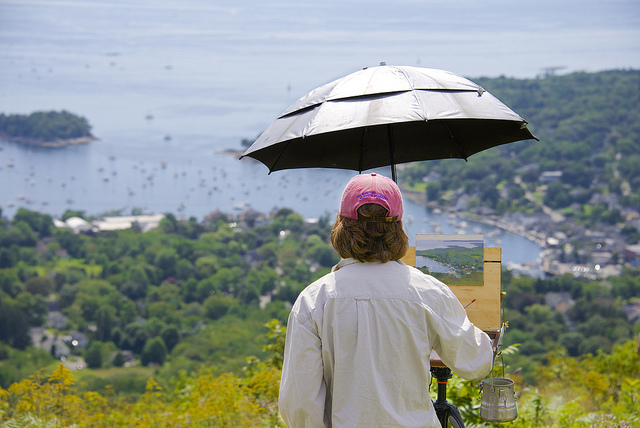What is the significance of the umbrella being used by the person? The umbrella is likely serving a dual purpose. Primarily, it could provide shade, which would help to control the light falling both on the artist and the canvas, ensuring consistent lighting while painting. Additionally, it may offer protection from the elements, allowing the artist to continue working despite changes in weather. How does the location where the artist is painting influence their work? Painting from such a high vantage point provides a grand, panoramic view of the landscape, which can offer inspiration and a wide range of scenic elements to incorporate into the artwork. The elevated position overlooks a harbor, which may add a sense of depth and vastness to the painting, possibly evoking feelings of awe or tranquility in viewers. 